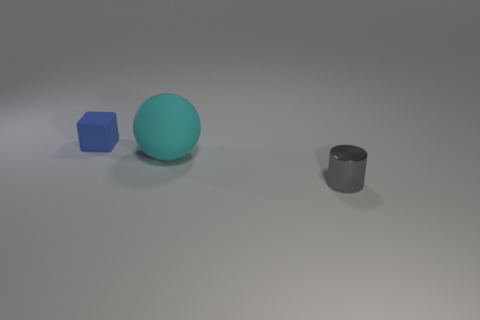Add 1 rubber cubes. How many objects exist? 4 Subtract 0 gray blocks. How many objects are left? 3 Subtract all blocks. How many objects are left? 2 Subtract all small blue matte blocks. Subtract all small metal cylinders. How many objects are left? 1 Add 2 small gray objects. How many small gray objects are left? 3 Add 2 tiny cyan matte spheres. How many tiny cyan matte spheres exist? 2 